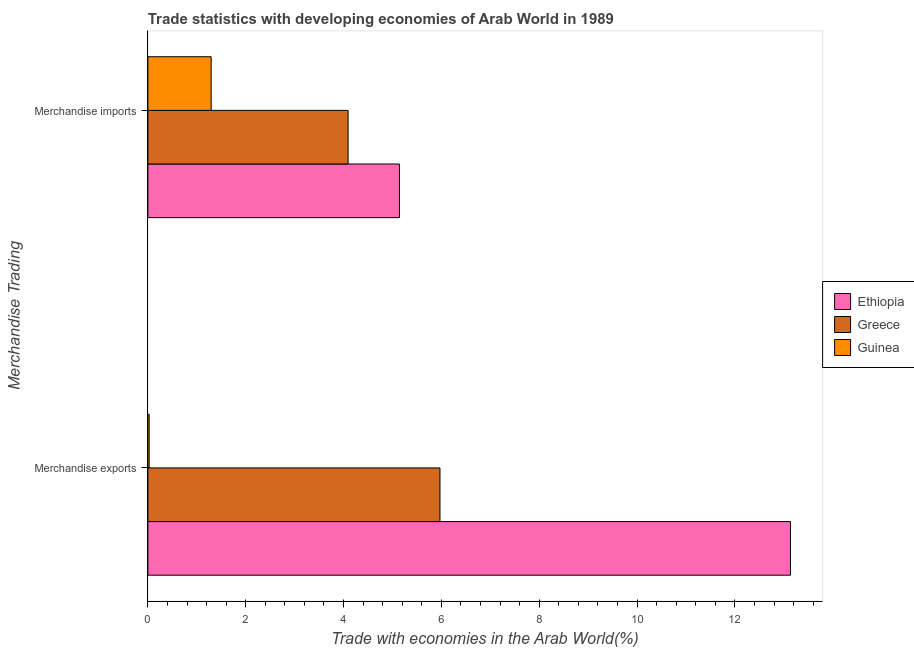Are the number of bars per tick equal to the number of legend labels?
Give a very brief answer. Yes. Are the number of bars on each tick of the Y-axis equal?
Offer a very short reply. Yes. How many bars are there on the 1st tick from the bottom?
Make the answer very short. 3. What is the label of the 1st group of bars from the top?
Give a very brief answer. Merchandise imports. What is the merchandise exports in Guinea?
Your answer should be very brief. 0.03. Across all countries, what is the maximum merchandise exports?
Offer a terse response. 13.14. Across all countries, what is the minimum merchandise imports?
Your response must be concise. 1.29. In which country was the merchandise imports maximum?
Offer a very short reply. Ethiopia. In which country was the merchandise imports minimum?
Provide a succinct answer. Guinea. What is the total merchandise imports in the graph?
Your answer should be very brief. 10.53. What is the difference between the merchandise imports in Ethiopia and that in Greece?
Give a very brief answer. 1.05. What is the difference between the merchandise imports in Greece and the merchandise exports in Ethiopia?
Your response must be concise. -9.04. What is the average merchandise imports per country?
Make the answer very short. 3.51. What is the difference between the merchandise exports and merchandise imports in Guinea?
Ensure brevity in your answer.  -1.27. In how many countries, is the merchandise exports greater than 13.2 %?
Provide a short and direct response. 0. What is the ratio of the merchandise imports in Greece to that in Ethiopia?
Offer a terse response. 0.8. In how many countries, is the merchandise exports greater than the average merchandise exports taken over all countries?
Your answer should be very brief. 1. What does the 3rd bar from the top in Merchandise imports represents?
Make the answer very short. Ethiopia. What does the 3rd bar from the bottom in Merchandise imports represents?
Keep it short and to the point. Guinea. How many bars are there?
Offer a very short reply. 6. How many countries are there in the graph?
Give a very brief answer. 3. What is the difference between two consecutive major ticks on the X-axis?
Your answer should be very brief. 2. Does the graph contain any zero values?
Keep it short and to the point. No. Where does the legend appear in the graph?
Offer a terse response. Center right. How many legend labels are there?
Offer a terse response. 3. How are the legend labels stacked?
Offer a terse response. Vertical. What is the title of the graph?
Offer a very short reply. Trade statistics with developing economies of Arab World in 1989. What is the label or title of the X-axis?
Your answer should be compact. Trade with economies in the Arab World(%). What is the label or title of the Y-axis?
Offer a terse response. Merchandise Trading. What is the Trade with economies in the Arab World(%) in Ethiopia in Merchandise exports?
Give a very brief answer. 13.14. What is the Trade with economies in the Arab World(%) of Greece in Merchandise exports?
Ensure brevity in your answer.  5.97. What is the Trade with economies in the Arab World(%) in Guinea in Merchandise exports?
Provide a succinct answer. 0.03. What is the Trade with economies in the Arab World(%) in Ethiopia in Merchandise imports?
Offer a very short reply. 5.14. What is the Trade with economies in the Arab World(%) of Greece in Merchandise imports?
Your response must be concise. 4.09. What is the Trade with economies in the Arab World(%) of Guinea in Merchandise imports?
Offer a very short reply. 1.29. Across all Merchandise Trading, what is the maximum Trade with economies in the Arab World(%) of Ethiopia?
Offer a very short reply. 13.14. Across all Merchandise Trading, what is the maximum Trade with economies in the Arab World(%) in Greece?
Provide a short and direct response. 5.97. Across all Merchandise Trading, what is the maximum Trade with economies in the Arab World(%) in Guinea?
Your answer should be very brief. 1.29. Across all Merchandise Trading, what is the minimum Trade with economies in the Arab World(%) of Ethiopia?
Ensure brevity in your answer.  5.14. Across all Merchandise Trading, what is the minimum Trade with economies in the Arab World(%) in Greece?
Your answer should be very brief. 4.09. Across all Merchandise Trading, what is the minimum Trade with economies in the Arab World(%) in Guinea?
Keep it short and to the point. 0.03. What is the total Trade with economies in the Arab World(%) of Ethiopia in the graph?
Keep it short and to the point. 18.28. What is the total Trade with economies in the Arab World(%) of Greece in the graph?
Offer a very short reply. 10.06. What is the total Trade with economies in the Arab World(%) of Guinea in the graph?
Give a very brief answer. 1.32. What is the difference between the Trade with economies in the Arab World(%) in Ethiopia in Merchandise exports and that in Merchandise imports?
Offer a very short reply. 7.99. What is the difference between the Trade with economies in the Arab World(%) of Greece in Merchandise exports and that in Merchandise imports?
Provide a short and direct response. 1.88. What is the difference between the Trade with economies in the Arab World(%) in Guinea in Merchandise exports and that in Merchandise imports?
Your answer should be very brief. -1.27. What is the difference between the Trade with economies in the Arab World(%) in Ethiopia in Merchandise exports and the Trade with economies in the Arab World(%) in Greece in Merchandise imports?
Give a very brief answer. 9.04. What is the difference between the Trade with economies in the Arab World(%) of Ethiopia in Merchandise exports and the Trade with economies in the Arab World(%) of Guinea in Merchandise imports?
Give a very brief answer. 11.84. What is the difference between the Trade with economies in the Arab World(%) in Greece in Merchandise exports and the Trade with economies in the Arab World(%) in Guinea in Merchandise imports?
Offer a terse response. 4.68. What is the average Trade with economies in the Arab World(%) of Ethiopia per Merchandise Trading?
Provide a short and direct response. 9.14. What is the average Trade with economies in the Arab World(%) in Greece per Merchandise Trading?
Ensure brevity in your answer.  5.03. What is the average Trade with economies in the Arab World(%) of Guinea per Merchandise Trading?
Offer a terse response. 0.66. What is the difference between the Trade with economies in the Arab World(%) in Ethiopia and Trade with economies in the Arab World(%) in Greece in Merchandise exports?
Provide a succinct answer. 7.16. What is the difference between the Trade with economies in the Arab World(%) of Ethiopia and Trade with economies in the Arab World(%) of Guinea in Merchandise exports?
Offer a terse response. 13.11. What is the difference between the Trade with economies in the Arab World(%) in Greece and Trade with economies in the Arab World(%) in Guinea in Merchandise exports?
Provide a short and direct response. 5.94. What is the difference between the Trade with economies in the Arab World(%) in Ethiopia and Trade with economies in the Arab World(%) in Guinea in Merchandise imports?
Provide a succinct answer. 3.85. What is the difference between the Trade with economies in the Arab World(%) in Greece and Trade with economies in the Arab World(%) in Guinea in Merchandise imports?
Give a very brief answer. 2.8. What is the ratio of the Trade with economies in the Arab World(%) in Ethiopia in Merchandise exports to that in Merchandise imports?
Give a very brief answer. 2.55. What is the ratio of the Trade with economies in the Arab World(%) in Greece in Merchandise exports to that in Merchandise imports?
Your answer should be compact. 1.46. What is the ratio of the Trade with economies in the Arab World(%) of Guinea in Merchandise exports to that in Merchandise imports?
Keep it short and to the point. 0.02. What is the difference between the highest and the second highest Trade with economies in the Arab World(%) in Ethiopia?
Your response must be concise. 7.99. What is the difference between the highest and the second highest Trade with economies in the Arab World(%) in Greece?
Offer a terse response. 1.88. What is the difference between the highest and the second highest Trade with economies in the Arab World(%) of Guinea?
Your answer should be very brief. 1.27. What is the difference between the highest and the lowest Trade with economies in the Arab World(%) in Ethiopia?
Provide a short and direct response. 7.99. What is the difference between the highest and the lowest Trade with economies in the Arab World(%) of Greece?
Your answer should be compact. 1.88. What is the difference between the highest and the lowest Trade with economies in the Arab World(%) in Guinea?
Ensure brevity in your answer.  1.27. 